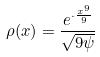Convert formula to latex. <formula><loc_0><loc_0><loc_500><loc_500>\rho ( x ) = \frac { e ^ { \cdot \frac { x ^ { 9 } } { 9 } } } { \sqrt { 9 \psi } }</formula> 